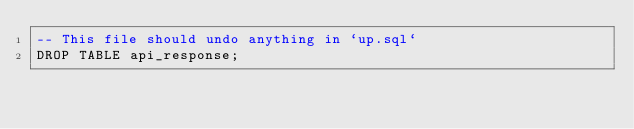<code> <loc_0><loc_0><loc_500><loc_500><_SQL_>-- This file should undo anything in `up.sql`
DROP TABLE api_response;
</code> 